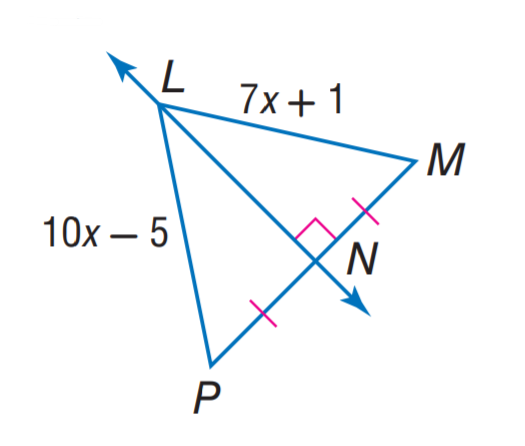Answer the mathemtical geometry problem and directly provide the correct option letter.
Question: Find L P.
Choices: A: 7 B: 10 C: 12 D: 15 D 